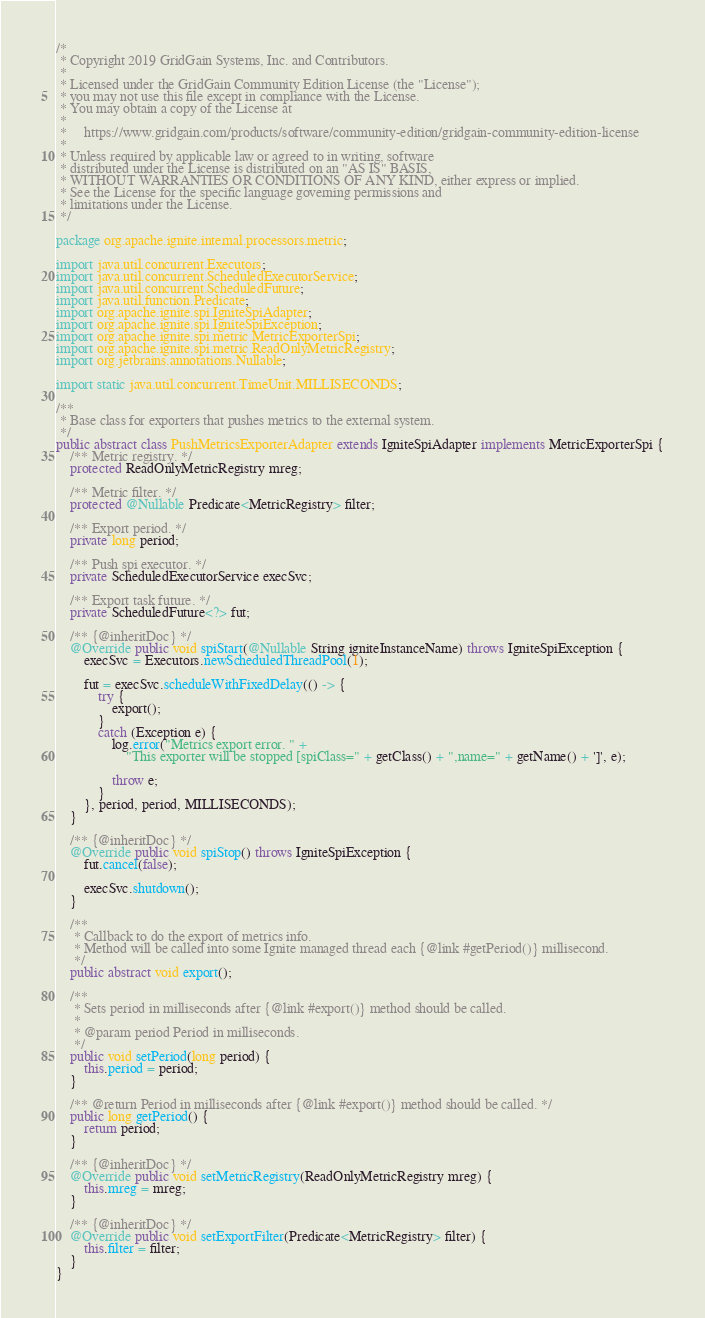Convert code to text. <code><loc_0><loc_0><loc_500><loc_500><_Java_>/*
 * Copyright 2019 GridGain Systems, Inc. and Contributors.
 *
 * Licensed under the GridGain Community Edition License (the "License");
 * you may not use this file except in compliance with the License.
 * You may obtain a copy of the License at
 *
 *     https://www.gridgain.com/products/software/community-edition/gridgain-community-edition-license
 *
 * Unless required by applicable law or agreed to in writing, software
 * distributed under the License is distributed on an "AS IS" BASIS,
 * WITHOUT WARRANTIES OR CONDITIONS OF ANY KIND, either express or implied.
 * See the License for the specific language governing permissions and
 * limitations under the License.
 */

package org.apache.ignite.internal.processors.metric;

import java.util.concurrent.Executors;
import java.util.concurrent.ScheduledExecutorService;
import java.util.concurrent.ScheduledFuture;
import java.util.function.Predicate;
import org.apache.ignite.spi.IgniteSpiAdapter;
import org.apache.ignite.spi.IgniteSpiException;
import org.apache.ignite.spi.metric.MetricExporterSpi;
import org.apache.ignite.spi.metric.ReadOnlyMetricRegistry;
import org.jetbrains.annotations.Nullable;

import static java.util.concurrent.TimeUnit.MILLISECONDS;

/**
 * Base class for exporters that pushes metrics to the external system.
 */
public abstract class PushMetricsExporterAdapter extends IgniteSpiAdapter implements MetricExporterSpi {
    /** Metric registry. */
    protected ReadOnlyMetricRegistry mreg;

    /** Metric filter. */
    protected @Nullable Predicate<MetricRegistry> filter;

    /** Export period. */
    private long period;

    /** Push spi executor. */
    private ScheduledExecutorService execSvc;

    /** Export task future. */
    private ScheduledFuture<?> fut;

    /** {@inheritDoc} */
    @Override public void spiStart(@Nullable String igniteInstanceName) throws IgniteSpiException {
        execSvc = Executors.newScheduledThreadPool(1);

        fut = execSvc.scheduleWithFixedDelay(() -> {
            try {
                export();
            }
            catch (Exception e) {
                log.error("Metrics export error. " +
                    "This exporter will be stopped [spiClass=" + getClass() + ",name=" + getName() + ']', e);

                throw e;
            }
        }, period, period, MILLISECONDS);
    }

    /** {@inheritDoc} */
    @Override public void spiStop() throws IgniteSpiException {
        fut.cancel(false);

        execSvc.shutdown();
    }

    /**
     * Callback to do the export of metrics info.
     * Method will be called into some Ignite managed thread each {@link #getPeriod()} millisecond.
     */
    public abstract void export();

    /**
     * Sets period in milliseconds after {@link #export()} method should be called.
     *
     * @param period Period in milliseconds.
     */
    public void setPeriod(long period) {
        this.period = period;
    }

    /** @return Period in milliseconds after {@link #export()} method should be called. */
    public long getPeriod() {
        return period;
    }

    /** {@inheritDoc} */
    @Override public void setMetricRegistry(ReadOnlyMetricRegistry mreg) {
        this.mreg = mreg;
    }

    /** {@inheritDoc} */
    @Override public void setExportFilter(Predicate<MetricRegistry> filter) {
        this.filter = filter;
    }
}
</code> 